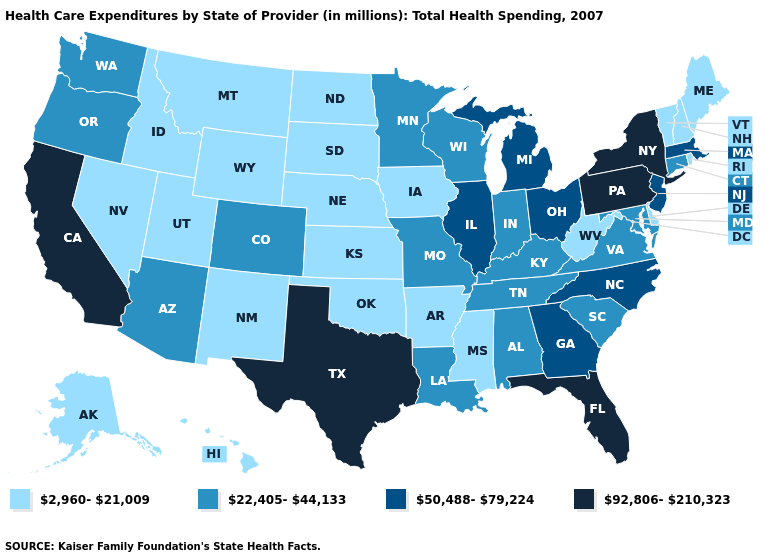Does the first symbol in the legend represent the smallest category?
Keep it brief. Yes. Which states have the highest value in the USA?
Concise answer only. California, Florida, New York, Pennsylvania, Texas. What is the value of Nebraska?
Answer briefly. 2,960-21,009. What is the value of Arizona?
Concise answer only. 22,405-44,133. Name the states that have a value in the range 22,405-44,133?
Answer briefly. Alabama, Arizona, Colorado, Connecticut, Indiana, Kentucky, Louisiana, Maryland, Minnesota, Missouri, Oregon, South Carolina, Tennessee, Virginia, Washington, Wisconsin. How many symbols are there in the legend?
Be succinct. 4. Name the states that have a value in the range 50,488-79,224?
Keep it brief. Georgia, Illinois, Massachusetts, Michigan, New Jersey, North Carolina, Ohio. Name the states that have a value in the range 92,806-210,323?
Write a very short answer. California, Florida, New York, Pennsylvania, Texas. What is the lowest value in states that border Montana?
Concise answer only. 2,960-21,009. Among the states that border Wisconsin , does Iowa have the highest value?
Quick response, please. No. Name the states that have a value in the range 22,405-44,133?
Short answer required. Alabama, Arizona, Colorado, Connecticut, Indiana, Kentucky, Louisiana, Maryland, Minnesota, Missouri, Oregon, South Carolina, Tennessee, Virginia, Washington, Wisconsin. What is the value of Minnesota?
Concise answer only. 22,405-44,133. Among the states that border Kansas , which have the highest value?
Keep it brief. Colorado, Missouri. Does the first symbol in the legend represent the smallest category?
Keep it brief. Yes. What is the value of South Carolina?
Quick response, please. 22,405-44,133. 